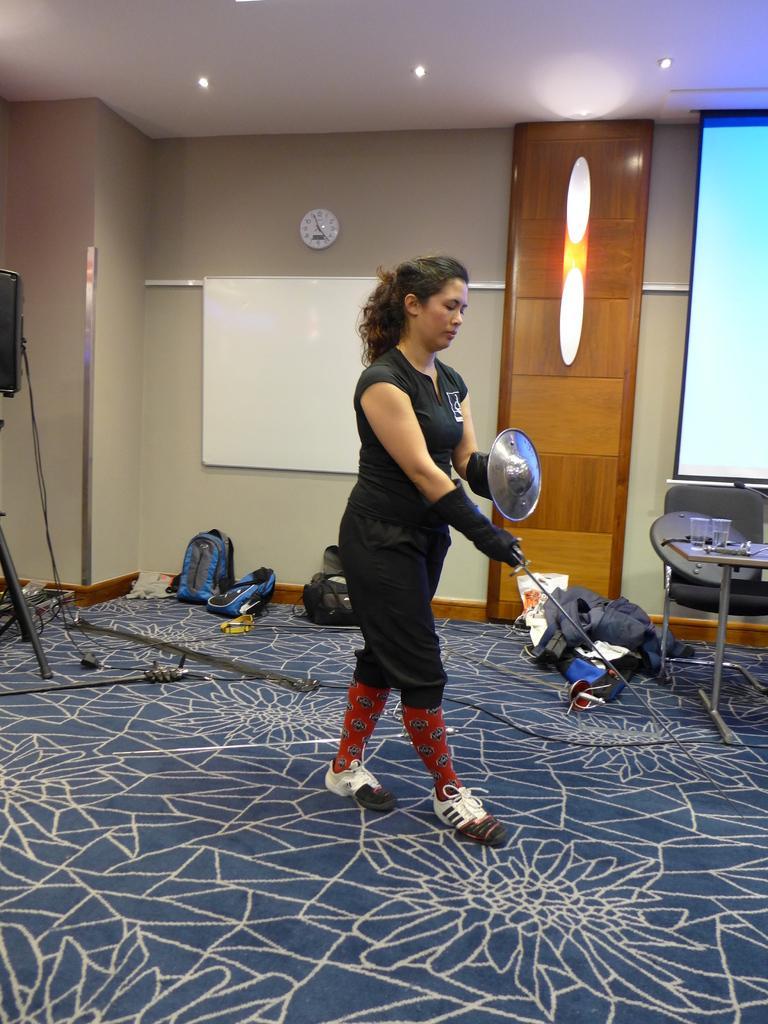Describe this image in one or two sentences. In this image there is a woman holding a sword and a shield in her hand, behind the woman on the floor there are bags, metal rods, glasses on the tables, chairs and some other objects, in the background of the image there is a wall clock, a board, lamps, a screen, a metal rod on the wall, at the top of the image there are lamps on the ceiling. 